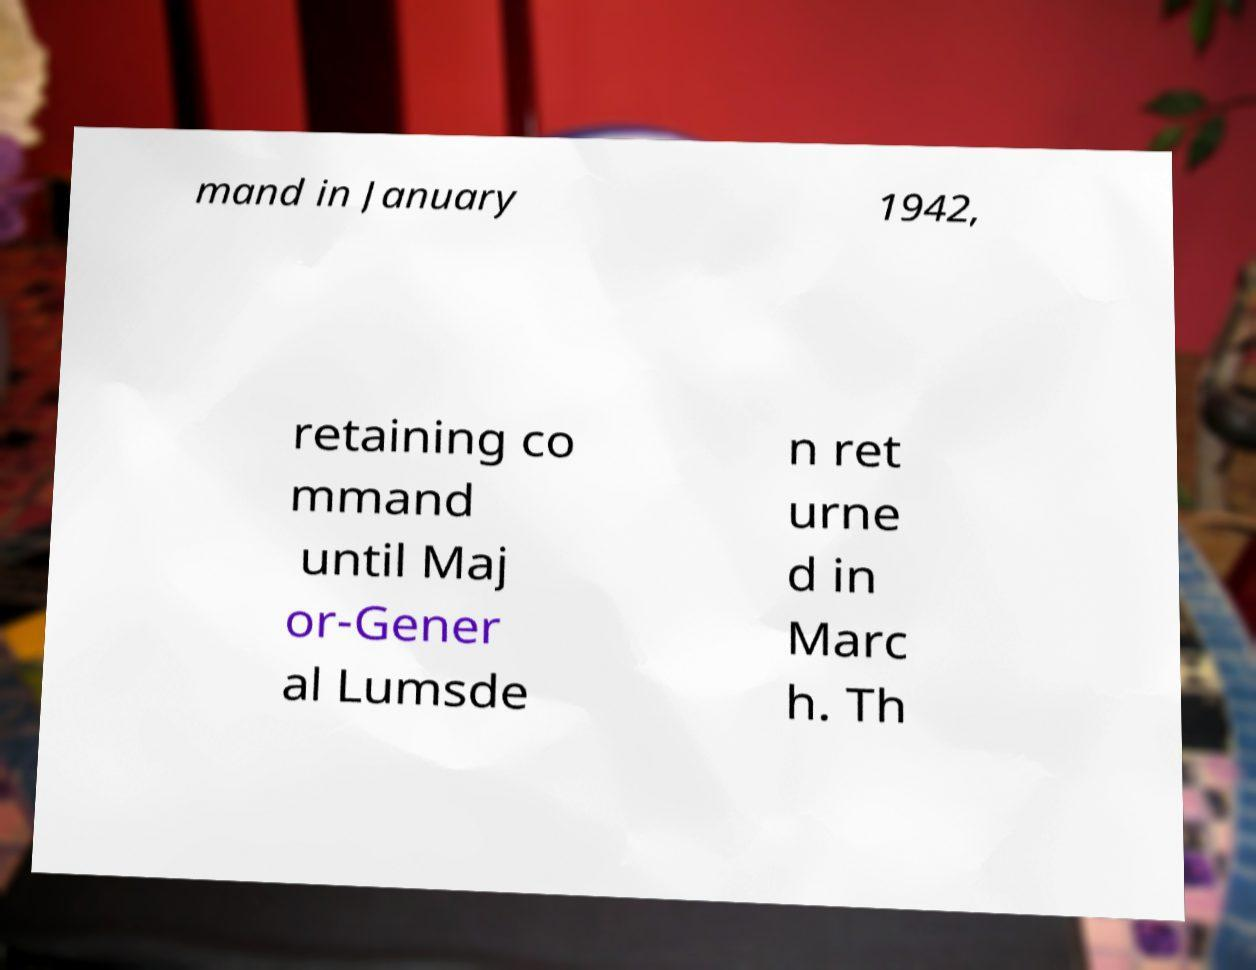I need the written content from this picture converted into text. Can you do that? mand in January 1942, retaining co mmand until Maj or-Gener al Lumsde n ret urne d in Marc h. Th 